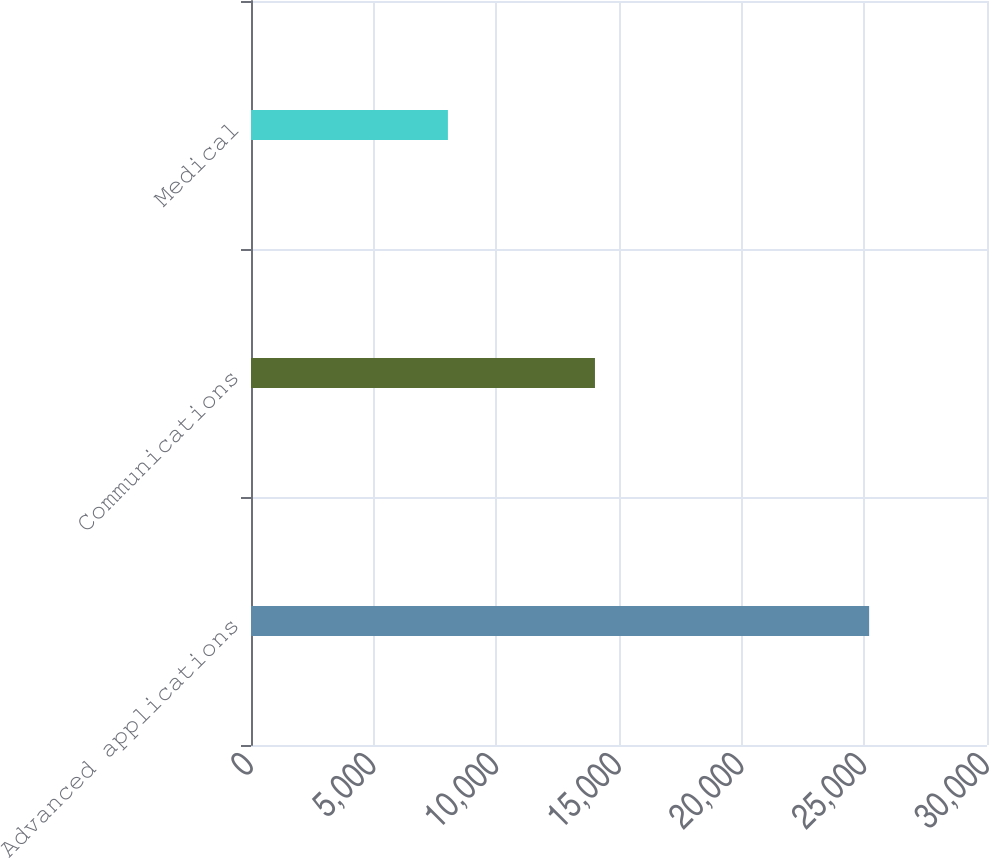<chart> <loc_0><loc_0><loc_500><loc_500><bar_chart><fcel>Advanced applications<fcel>Communications<fcel>Medical<nl><fcel>25196<fcel>14020<fcel>8026<nl></chart> 